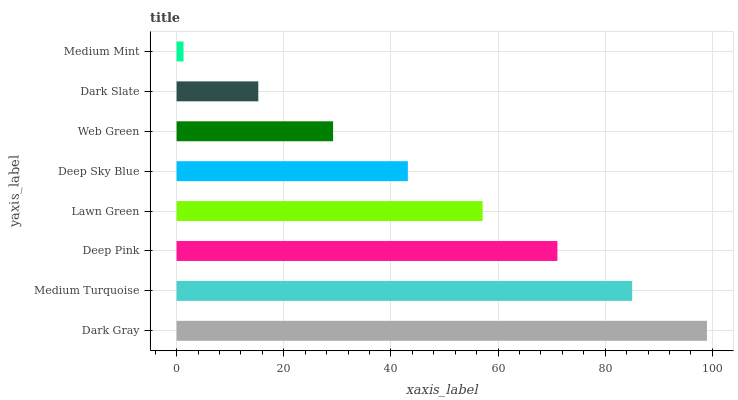Is Medium Mint the minimum?
Answer yes or no. Yes. Is Dark Gray the maximum?
Answer yes or no. Yes. Is Medium Turquoise the minimum?
Answer yes or no. No. Is Medium Turquoise the maximum?
Answer yes or no. No. Is Dark Gray greater than Medium Turquoise?
Answer yes or no. Yes. Is Medium Turquoise less than Dark Gray?
Answer yes or no. Yes. Is Medium Turquoise greater than Dark Gray?
Answer yes or no. No. Is Dark Gray less than Medium Turquoise?
Answer yes or no. No. Is Lawn Green the high median?
Answer yes or no. Yes. Is Deep Sky Blue the low median?
Answer yes or no. Yes. Is Dark Gray the high median?
Answer yes or no. No. Is Medium Mint the low median?
Answer yes or no. No. 